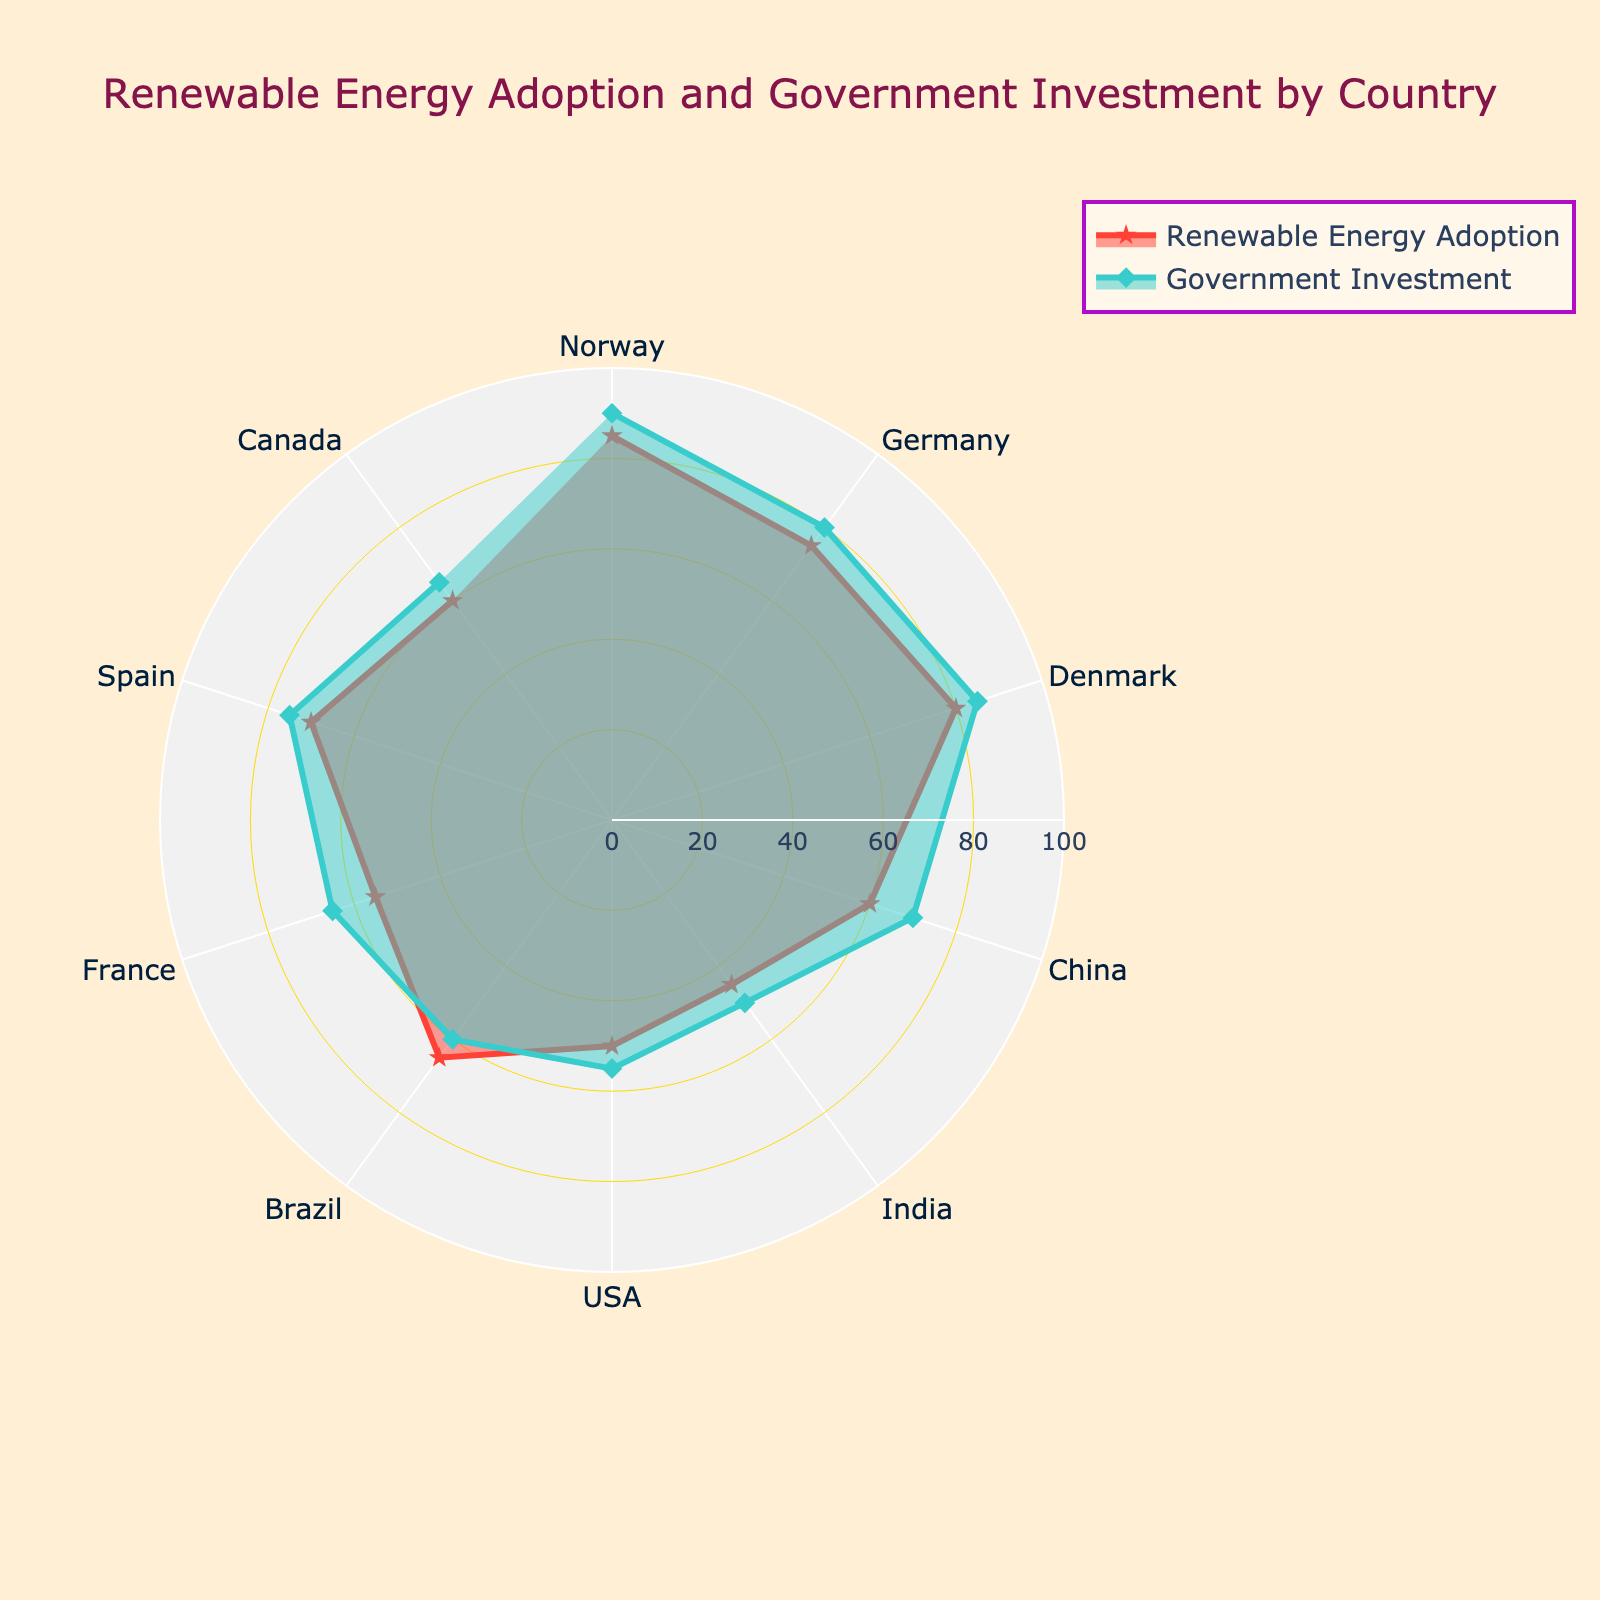What is the title of the radar chart? The title of the radar chart is located at the top of the figure and provides a summary of what the chart represents. The title in this case is "Renewable Energy Adoption and Government Investment by Country".
Answer: Renewable Energy Adoption and Government Investment by Country What is the maximum value on the radial axis? The radial axis range indicates the scale for the data points in the radar chart. It ranges from 0 to 100, with the maximum value clearly labeled at 100.
Answer: 100 Which country has the highest government investment in renewable energy? By inspecting the data points on the radar chart, we can see that Norway has the highest government investment value, with a score of 90.
Answer: Norway Which country shows the lowest renewable energy adoption? On the radar chart, India has the lowest radial position for renewable energy adoption, with a score of 45.
Answer: India How do Norway and Germany compare in terms of renewable energy adoption? Comparing the radial distances of Norway and Germany on the radar chart under the "Renewable Energy Adoption" trace, Norway has a higher value (85) compared to Germany (75).
Answer: Norway has a higher value than Germany What is the average value of government investment for Denmark and France? To find the average, sum the government investment values for Denmark (85) and France (65) and divide by 2. The calculation is (85 + 65) / 2 = 75.
Answer: 75 Are there any countries with equal values in both renewable energy adoption and government investment? By examining the radar chart, both values for each country can be compared. No country has exactly equal values for both measures.
Answer: No Which country has the most balanced (minimal difference) renewable energy adoption and government investment values? By calculating the difference between the values for each country, Brazil has the smallest difference of 5 (65 for renewable and 60 for investment).
Answer: Brazil What is the largest gap between renewable energy adoption and government investment for any country? The country with the largest difference between the two metrics is Norway, with a difference of 5 (90 for investment and 85 for renewable adoption).
Answer: 5 Which country has the closest values to the median value of both renewable energy adoption and government investment? By ordering the values and finding the median, the median adoption value is 60, and the median investment value is also 60. The country closest to these medians is China with values 60 and 70.
Answer: China 